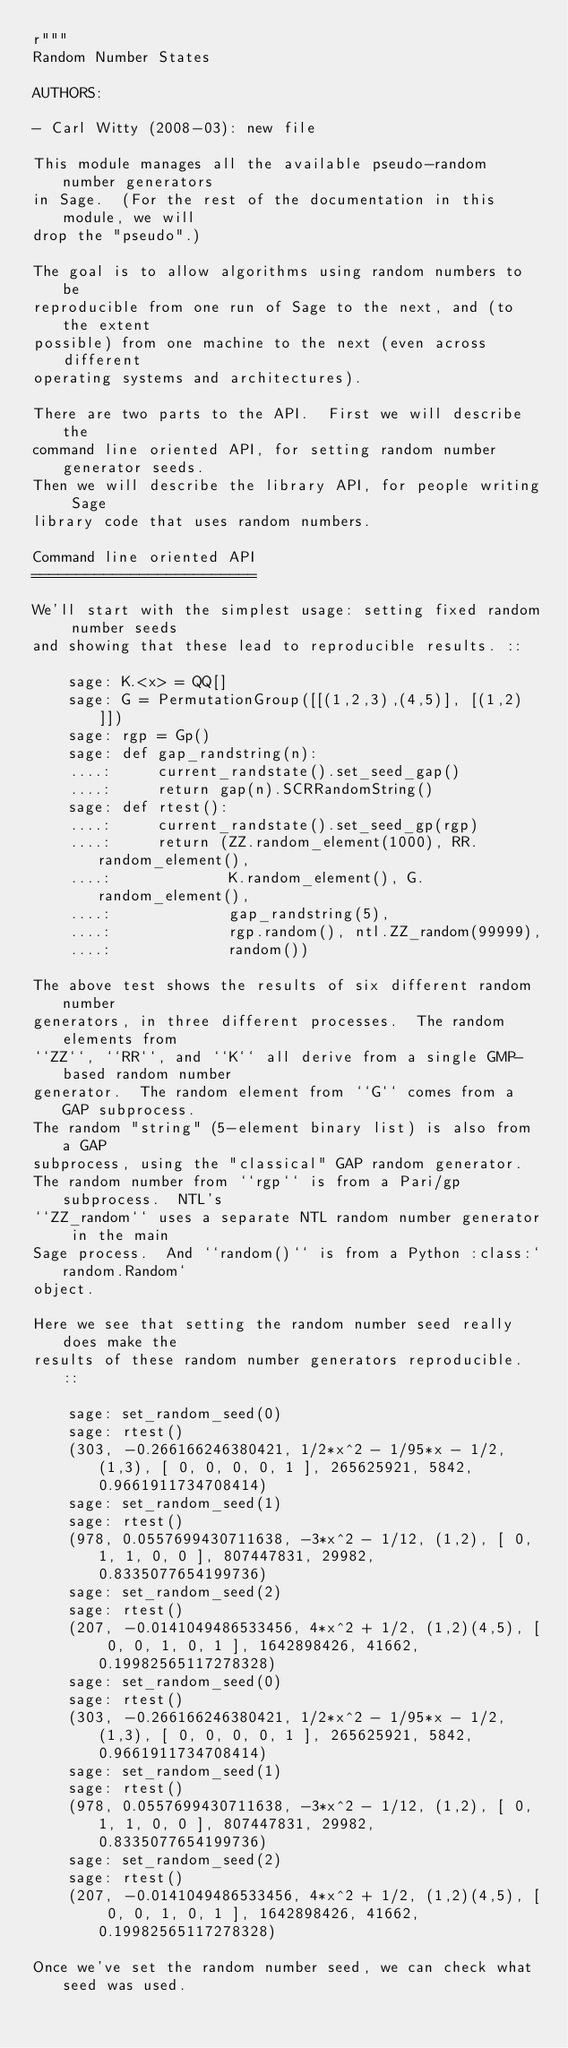Convert code to text. <code><loc_0><loc_0><loc_500><loc_500><_Cython_>r"""
Random Number States

AUTHORS:

- Carl Witty (2008-03): new file

This module manages all the available pseudo-random number generators
in Sage.  (For the rest of the documentation in this module, we will
drop the "pseudo".)

The goal is to allow algorithms using random numbers to be
reproducible from one run of Sage to the next, and (to the extent
possible) from one machine to the next (even across different
operating systems and architectures).

There are two parts to the API.  First we will describe the
command line oriented API, for setting random number generator seeds.
Then we will describe the library API, for people writing Sage
library code that uses random numbers.

Command line oriented API
=========================

We'll start with the simplest usage: setting fixed random number seeds
and showing that these lead to reproducible results. ::

    sage: K.<x> = QQ[]
    sage: G = PermutationGroup([[(1,2,3),(4,5)], [(1,2)]])
    sage: rgp = Gp()
    sage: def gap_randstring(n):
    ....:     current_randstate().set_seed_gap()
    ....:     return gap(n).SCRRandomString()
    sage: def rtest():
    ....:     current_randstate().set_seed_gp(rgp)
    ....:     return (ZZ.random_element(1000), RR.random_element(),
    ....:             K.random_element(), G.random_element(),
    ....:             gap_randstring(5),
    ....:             rgp.random(), ntl.ZZ_random(99999),
    ....:             random())

The above test shows the results of six different random number
generators, in three different processes.  The random elements from
``ZZ``, ``RR``, and ``K`` all derive from a single GMP-based random number
generator.  The random element from ``G`` comes from a GAP subprocess.
The random "string" (5-element binary list) is also from a GAP
subprocess, using the "classical" GAP random generator.
The random number from ``rgp`` is from a Pari/gp subprocess.  NTL's
``ZZ_random`` uses a separate NTL random number generator in the main
Sage process.  And ``random()`` is from a Python :class:`random.Random`
object.

Here we see that setting the random number seed really does make the
results of these random number generators reproducible. ::

    sage: set_random_seed(0)
    sage: rtest()
    (303, -0.266166246380421, 1/2*x^2 - 1/95*x - 1/2, (1,3), [ 0, 0, 0, 0, 1 ], 265625921, 5842, 0.9661911734708414)
    sage: set_random_seed(1)
    sage: rtest()
    (978, 0.0557699430711638, -3*x^2 - 1/12, (1,2), [ 0, 1, 1, 0, 0 ], 807447831, 29982, 0.8335077654199736)
    sage: set_random_seed(2)
    sage: rtest()
    (207, -0.0141049486533456, 4*x^2 + 1/2, (1,2)(4,5), [ 0, 0, 1, 0, 1 ], 1642898426, 41662, 0.19982565117278328)
    sage: set_random_seed(0)
    sage: rtest()
    (303, -0.266166246380421, 1/2*x^2 - 1/95*x - 1/2, (1,3), [ 0, 0, 0, 0, 1 ], 265625921, 5842, 0.9661911734708414)
    sage: set_random_seed(1)
    sage: rtest()
    (978, 0.0557699430711638, -3*x^2 - 1/12, (1,2), [ 0, 1, 1, 0, 0 ], 807447831, 29982, 0.8335077654199736)
    sage: set_random_seed(2)
    sage: rtest()
    (207, -0.0141049486533456, 4*x^2 + 1/2, (1,2)(4,5), [ 0, 0, 1, 0, 1 ], 1642898426, 41662, 0.19982565117278328)

Once we've set the random number seed, we can check what seed was used.</code> 